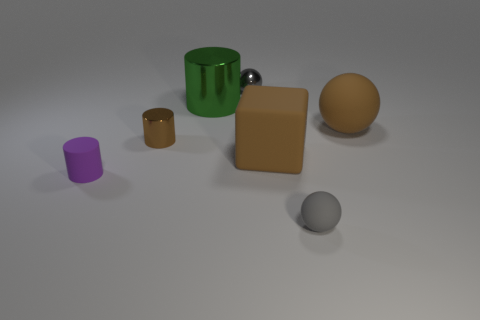What is the material of the tiny brown thing that is the same shape as the purple rubber object?
Provide a succinct answer. Metal. There is a tiny gray thing that is on the right side of the ball that is left of the large matte block; is there a brown object that is on the left side of it?
Your answer should be compact. Yes. There is a purple object; is it the same shape as the tiny gray object that is in front of the small purple object?
Give a very brief answer. No. Are there any other things that have the same color as the small matte cylinder?
Your answer should be very brief. No. There is a tiny object that is on the right side of the gray shiny thing; is it the same color as the big matte thing that is to the right of the matte cube?
Your answer should be compact. No. Are there any brown cubes?
Offer a terse response. Yes. Is there a big green ball that has the same material as the large green thing?
Offer a very short reply. No. Are there any other things that have the same material as the purple cylinder?
Make the answer very short. Yes. The small rubber cylinder has what color?
Keep it short and to the point. Purple. What is the shape of the tiny metallic object that is the same color as the matte cube?
Your answer should be compact. Cylinder. 